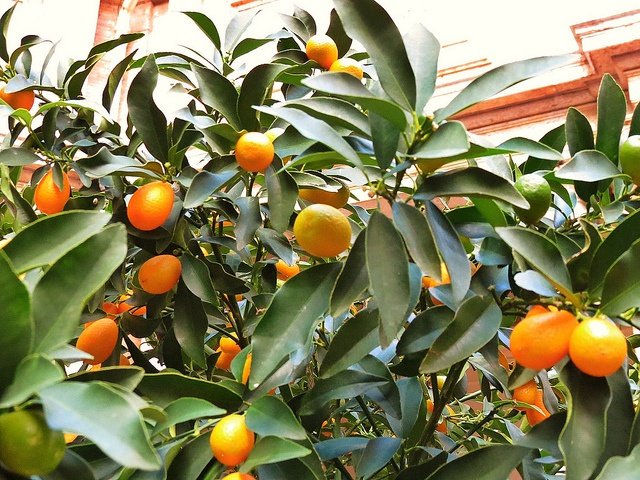Describe the objects in this image and their specific colors. I can see orange in ivory, orange, red, gold, and tan tones, orange in ivory, orange, red, and gold tones, orange in ivory, orange, olive, and khaki tones, orange in ivory, red, orange, and gold tones, and orange in ivory, red, gold, orange, and yellow tones in this image. 